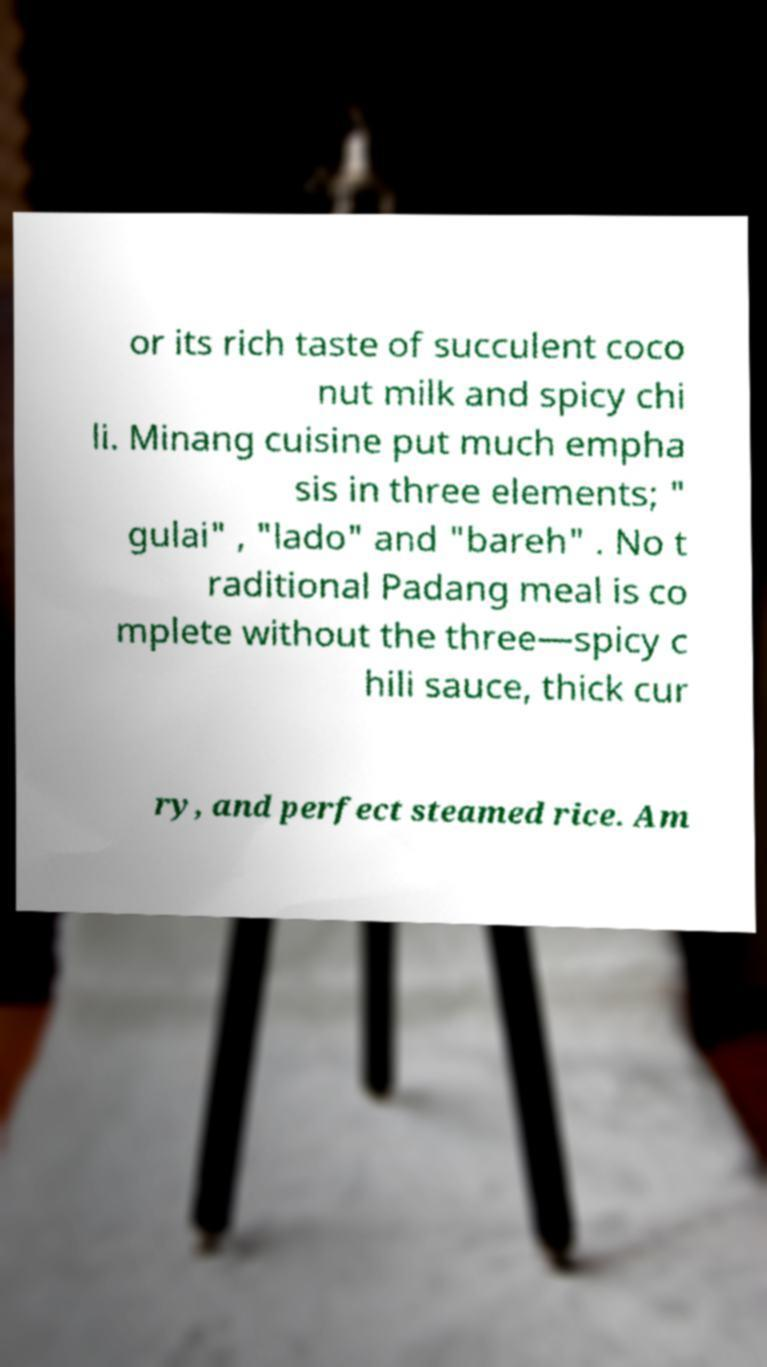Could you assist in decoding the text presented in this image and type it out clearly? or its rich taste of succulent coco nut milk and spicy chi li. Minang cuisine put much empha sis in three elements; " gulai" , "lado" and "bareh" . No t raditional Padang meal is co mplete without the three—spicy c hili sauce, thick cur ry, and perfect steamed rice. Am 